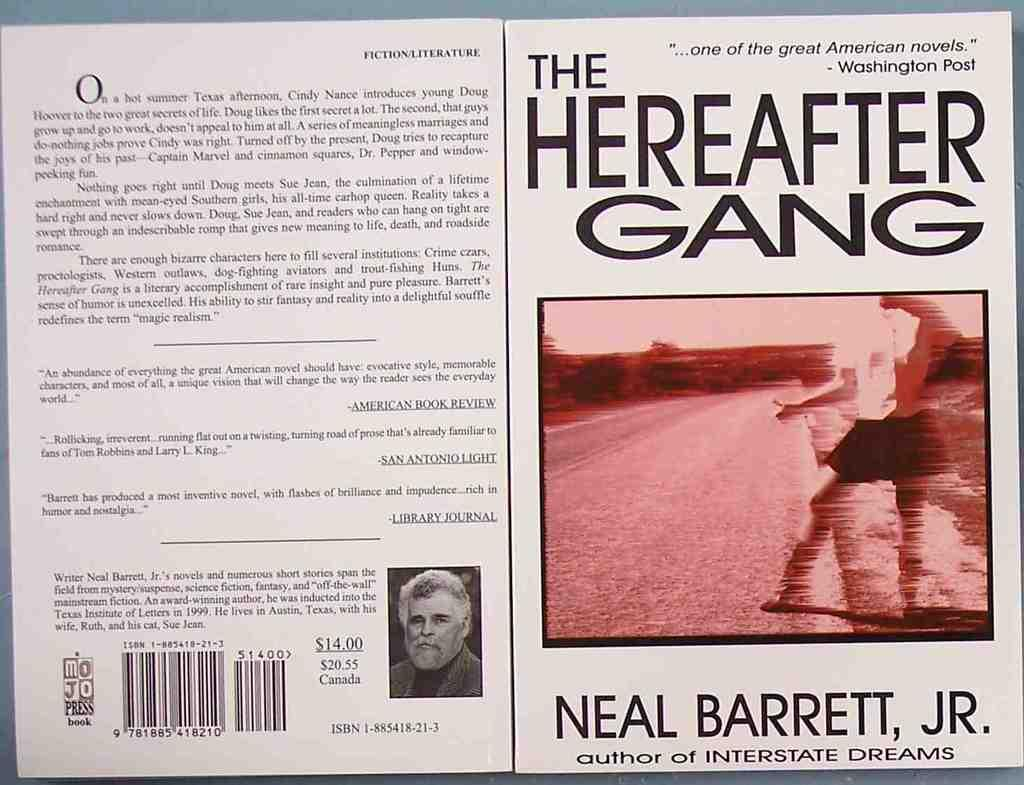<image>
Give a short and clear explanation of the subsequent image. front and back of book, the hereafter gang by neal barrett, jr 